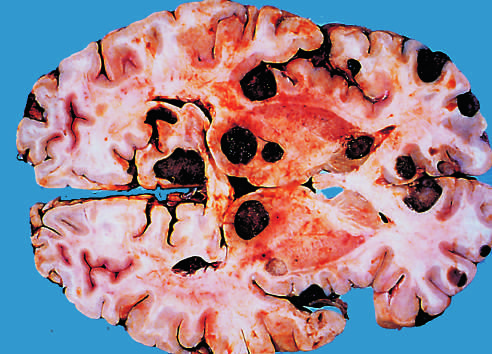what is the dark color of the tumor nodules in this specimen due to?
Answer the question using a single word or phrase. The presence of melanin 